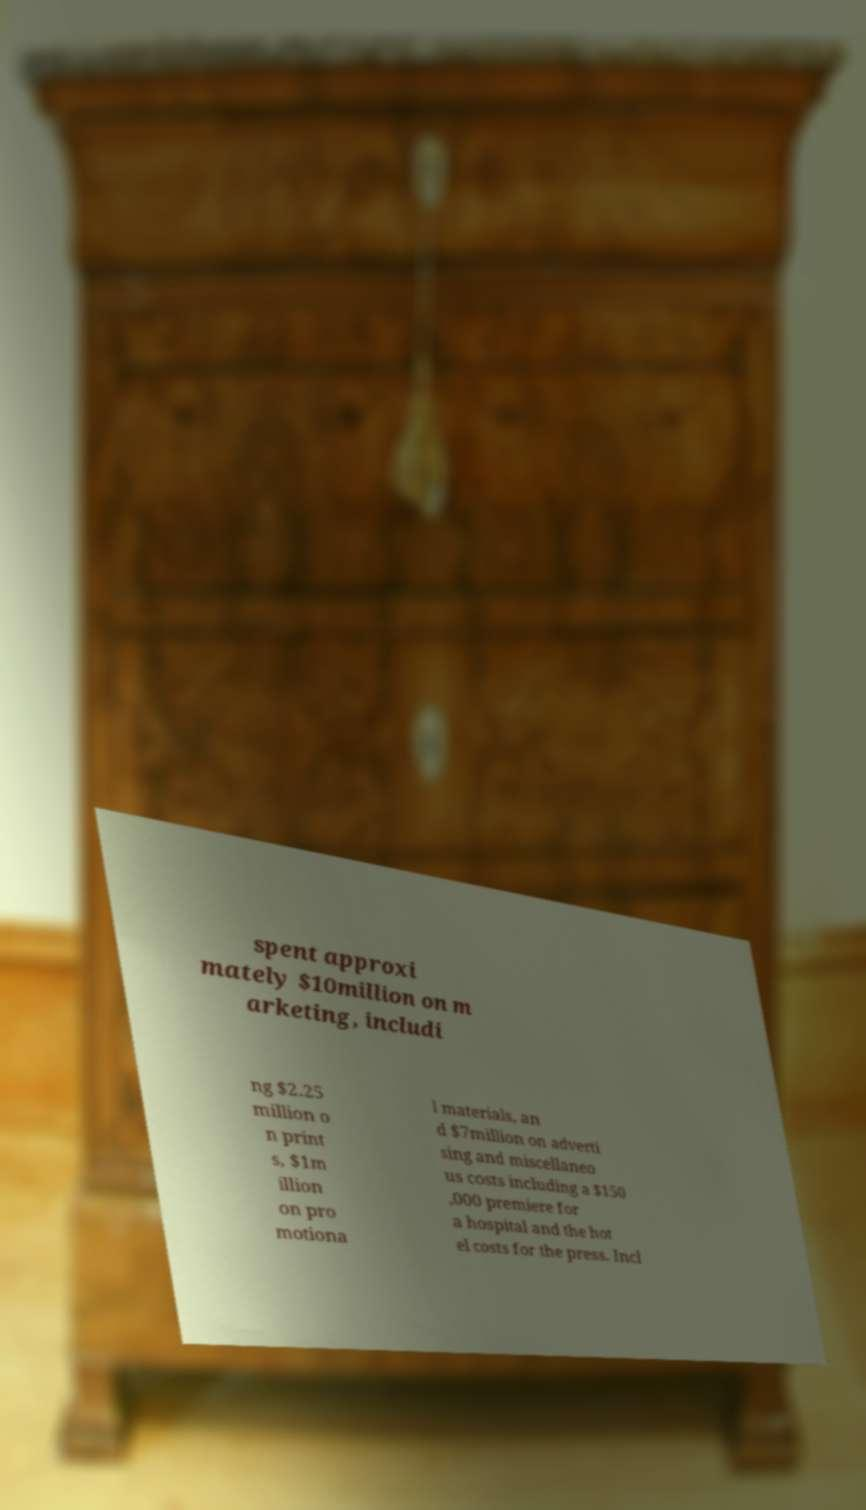Can you accurately transcribe the text from the provided image for me? spent approxi mately $10million on m arketing, includi ng $2.25 million o n print s, $1m illion on pro motiona l materials, an d $7million on adverti sing and miscellaneo us costs including a $150 ,000 premiere for a hospital and the hot el costs for the press. Incl 